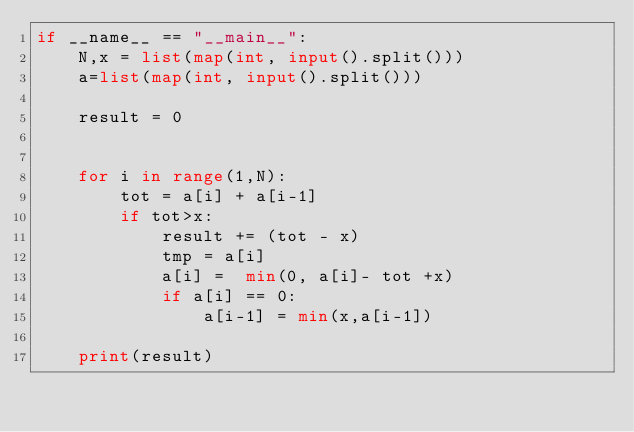Convert code to text. <code><loc_0><loc_0><loc_500><loc_500><_Python_>if __name__ == "__main__":
    N,x = list(map(int, input().split()))
    a=list(map(int, input().split()))

    result = 0


    for i in range(1,N):
        tot = a[i] + a[i-1]
        if tot>x:
            result += (tot - x)
            tmp = a[i]
            a[i] =  min(0, a[i]- tot +x)
            if a[i] == 0:
                a[i-1] = min(x,a[i-1])

    print(result)

</code> 